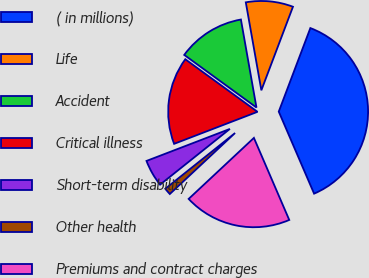Convert chart to OTSL. <chart><loc_0><loc_0><loc_500><loc_500><pie_chart><fcel>( in millions)<fcel>Life<fcel>Accident<fcel>Critical illness<fcel>Short-term disability<fcel>Other health<fcel>Premiums and contract charges<nl><fcel>37.77%<fcel>8.54%<fcel>12.2%<fcel>15.85%<fcel>4.89%<fcel>1.24%<fcel>19.51%<nl></chart> 